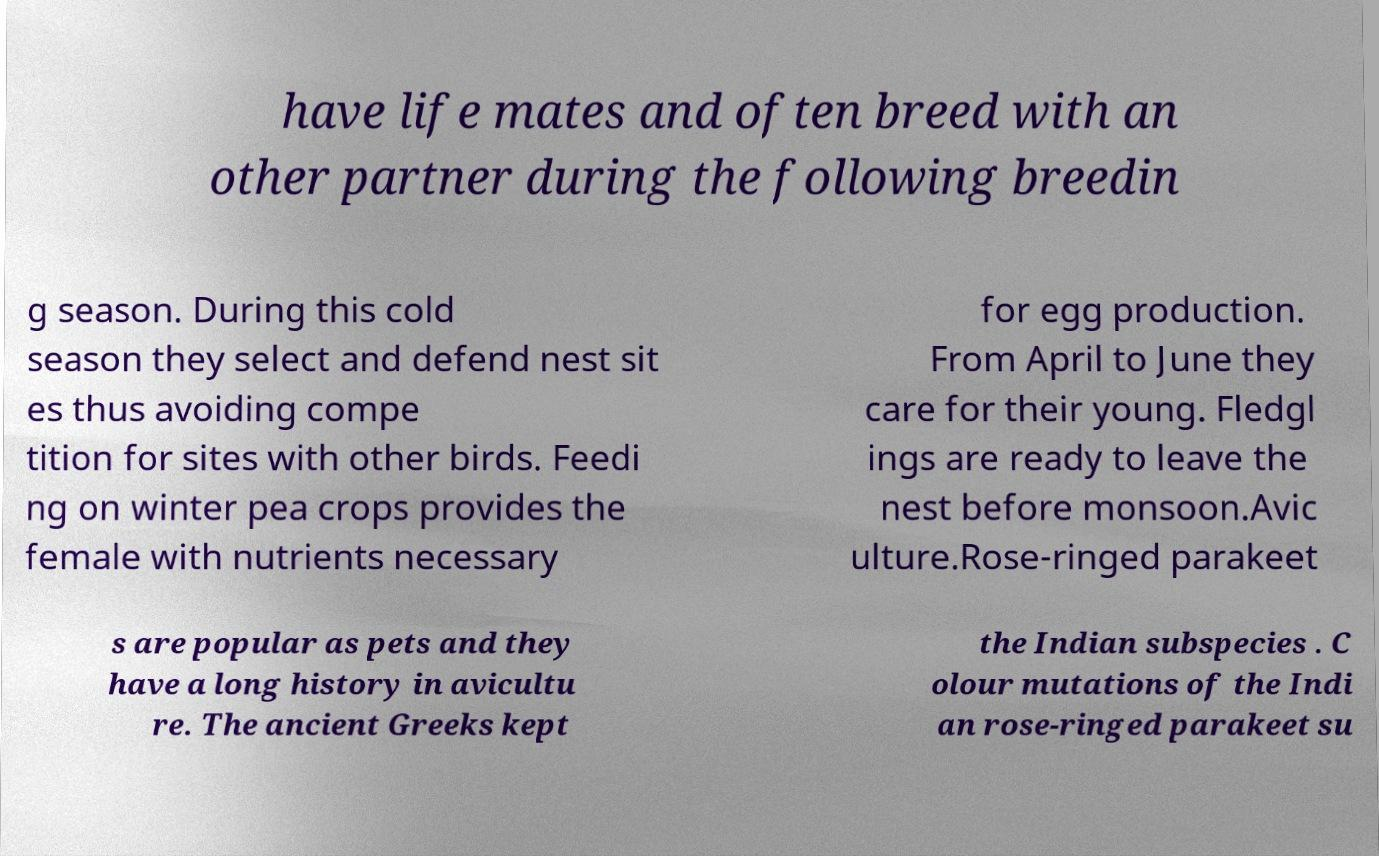For documentation purposes, I need the text within this image transcribed. Could you provide that? have life mates and often breed with an other partner during the following breedin g season. During this cold season they select and defend nest sit es thus avoiding compe tition for sites with other birds. Feedi ng on winter pea crops provides the female with nutrients necessary for egg production. From April to June they care for their young. Fledgl ings are ready to leave the nest before monsoon.Avic ulture.Rose-ringed parakeet s are popular as pets and they have a long history in avicultu re. The ancient Greeks kept the Indian subspecies . C olour mutations of the Indi an rose-ringed parakeet su 